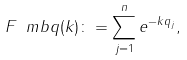<formula> <loc_0><loc_0><loc_500><loc_500>F _ { \ } m b q ( k ) \colon = \sum _ { j = 1 } ^ { n } e ^ { - k q _ { j } } ,</formula> 